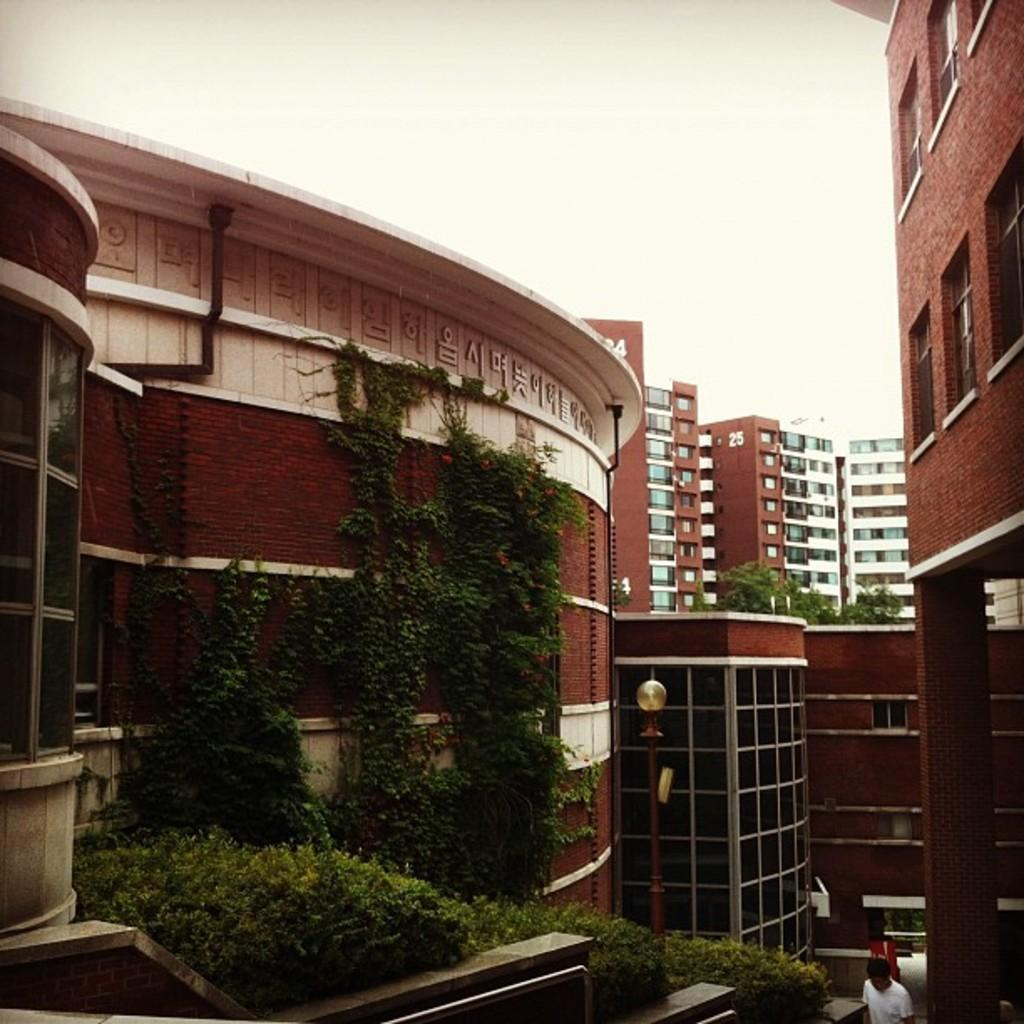Where is the man located in the image? The man is standing in the bottom right side of the image. What can be seen in the middle of the image? There are plants, trees, and buildings in the middle of the image. What is visible at the top of the image? Clouds and the sky are visible at the top of the image. What type of coast can be seen in the image? There is no coast visible in the image; it features a man, plants, trees, buildings, clouds, and the sky. 